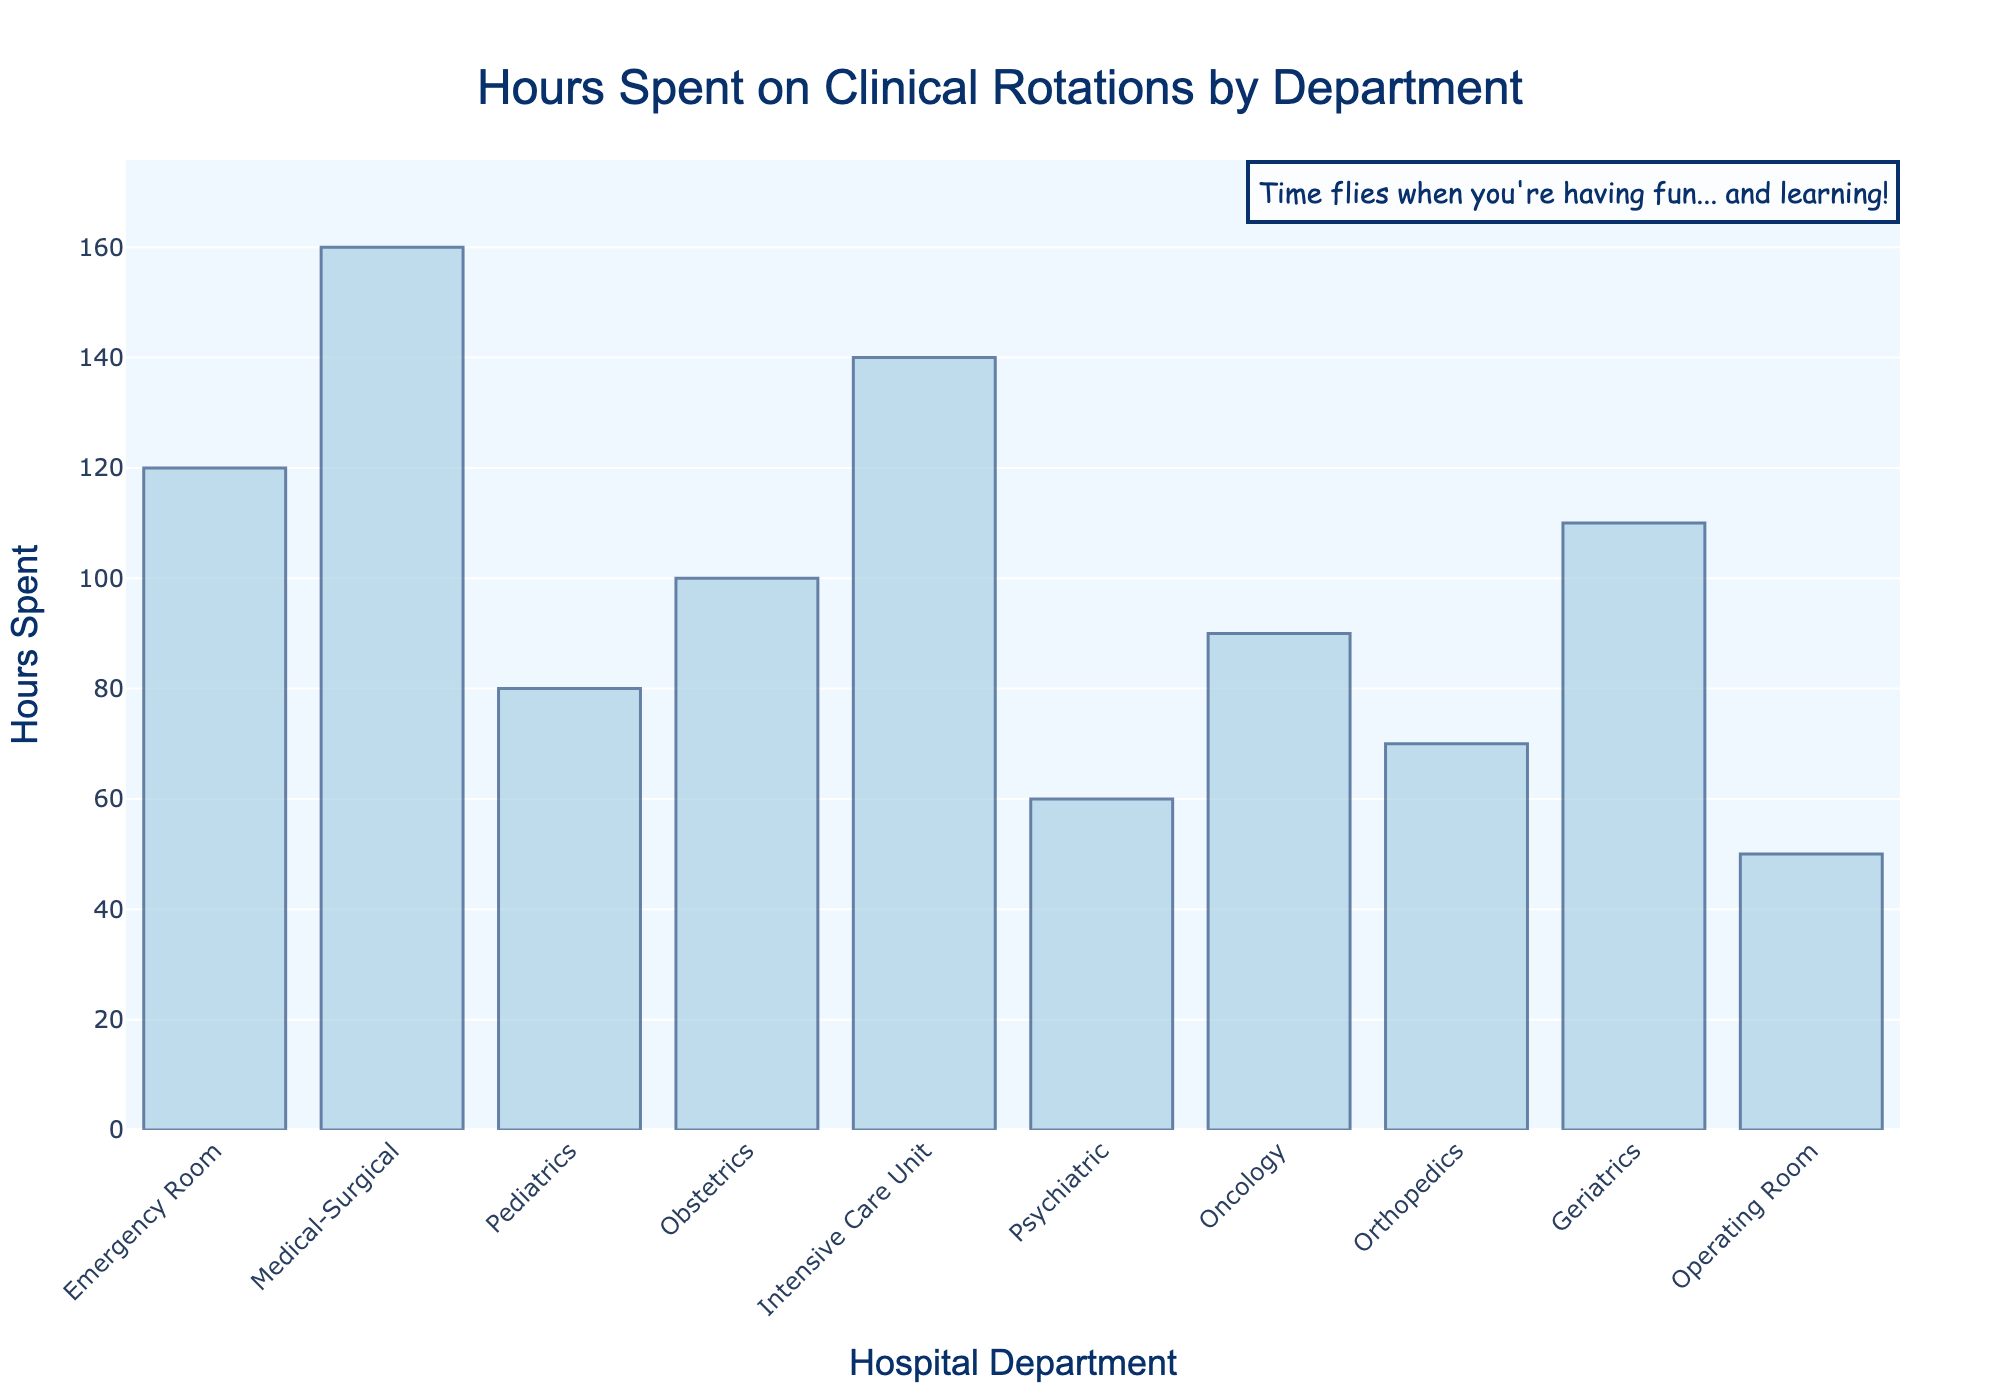Which department has the highest number of hours spent on clinical rotations? To find the department with the highest hours, look at the bar that reaches the highest on the histogram. The Medical-Surgical department has the tallest bar.
Answer: Medical-Surgical Which department has the lowest number of hours spent on clinical rotations? To identify the department with the lowest hours, look for the shortest bar on the histogram. The Operating Room department has the shortest bar.
Answer: Operating Room How many hours are spent on clinical rotations in the Pediatrics and Obstetrics departments combined? To find the total hours spent for Pediatrics and Obstetrics, add the hours of both departments: 80 (Pediatrics) + 100 (Obstetrics) = 180 hours.
Answer: 180 hours What is the difference in hours spent on clinical rotations between the Intensive Care Unit and Emergency Room departments? Subtract the hours spent in the Emergency Room from the Intensive Care Unit: 140 (Intensive Care Unit) - 120 (Emergency Room) = 20 hours.
Answer: 20 hours Which departments have more than 100 hours spent on clinical rotations? Identify the departments with bars reaching above the 100-hour mark. These departments are Medical-Surgical (160), Emergency Room (120), Intensive Care Unit (140), and Geriatrics (110).
Answer: Medical-Surgical, Emergency Room, Intensive Care Unit, Geriatrics Which department has 60 hours spent on clinical rotations? Look for the bar that corresponds to 60 hours. The Psychiatric department has 60 hours.
Answer: Psychiatric What's the average number of hours spent on clinical rotations across all the departments? To calculate the average, sum all the hours and divide by the number of departments: (120 + 160 + 80 + 100 + 140 + 60 + 90 + 70 + 110 + 50) / 10 = 980 / 10 = 98 hours.
Answer: 98 hours How many departments have less than 100 hours spent on clinical rotations? Count the number of bars that fall below the 100-hour mark. The departments are Pediatrics (80), Psychiatric (60), Oncology (90), Orthopedics (70), and Operating Room (50). There are 5 such departments.
Answer: 5 departments What is the total number of hours spent on clinical rotations in the Geriatrics and Oncology departments? To find the total hours for Geriatrics and Oncology, add the hours of both departments: 110 (Geriatrics) + 90 (Oncology) = 200 hours.
Answer: 200 hours What is the annotation text at the top of the histogram? Look at the text near the top of the histogram. The annotation reads: "Time flies when you're having fun... and learning!"
Answer: Time flies when you're having fun... and learning! 